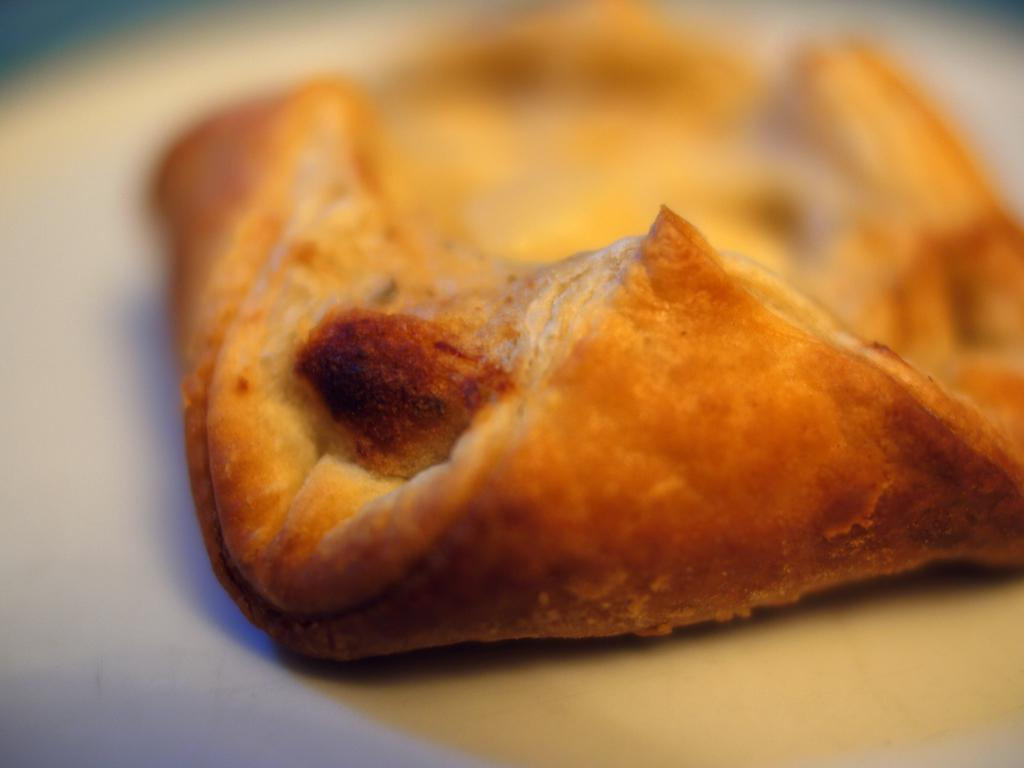What is on the plate that is visible in the image? The plate contains a puff pastry. What color is the plate in the image? The plate is white. Can you describe the background of the image? The background of the image is blurred. What type of tombstone can be seen in the cemetery in the image? There is no cemetery or tombstone present in the image; it features a white plate with a puff pastry. Is there a crook trying to steal the puff pastry in the image? There is no crook or any indication of theft in the image; it simply shows a plate with a puff pastry. 